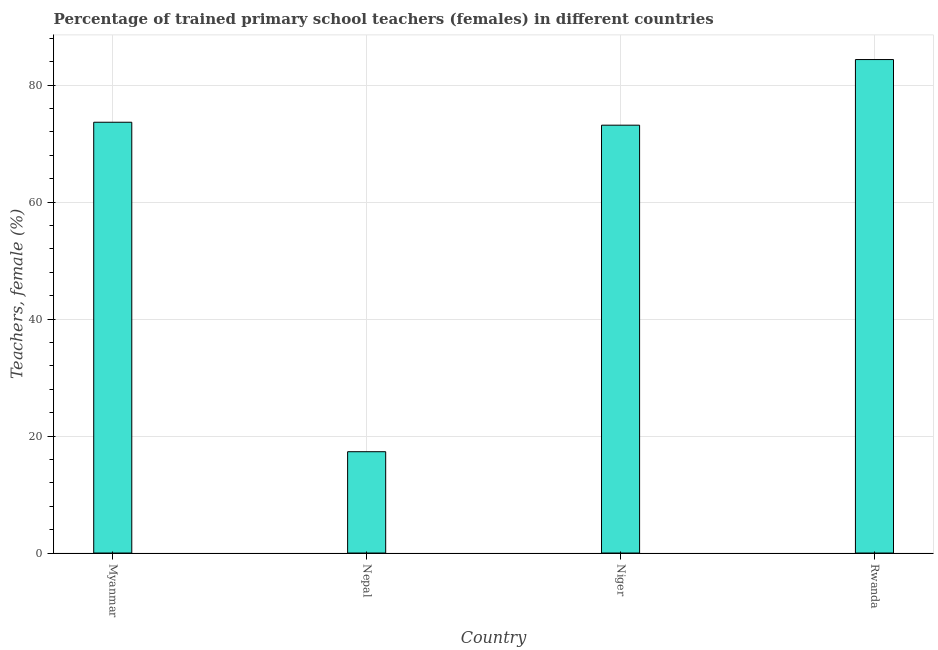What is the title of the graph?
Give a very brief answer. Percentage of trained primary school teachers (females) in different countries. What is the label or title of the X-axis?
Provide a succinct answer. Country. What is the label or title of the Y-axis?
Your answer should be very brief. Teachers, female (%). What is the percentage of trained female teachers in Myanmar?
Ensure brevity in your answer.  73.66. Across all countries, what is the maximum percentage of trained female teachers?
Offer a very short reply. 84.39. Across all countries, what is the minimum percentage of trained female teachers?
Ensure brevity in your answer.  17.32. In which country was the percentage of trained female teachers maximum?
Provide a short and direct response. Rwanda. In which country was the percentage of trained female teachers minimum?
Ensure brevity in your answer.  Nepal. What is the sum of the percentage of trained female teachers?
Offer a very short reply. 248.54. What is the difference between the percentage of trained female teachers in Niger and Rwanda?
Offer a terse response. -11.22. What is the average percentage of trained female teachers per country?
Give a very brief answer. 62.13. What is the median percentage of trained female teachers?
Give a very brief answer. 73.41. What is the ratio of the percentage of trained female teachers in Myanmar to that in Rwanda?
Make the answer very short. 0.87. Is the percentage of trained female teachers in Myanmar less than that in Rwanda?
Make the answer very short. Yes. What is the difference between the highest and the second highest percentage of trained female teachers?
Your answer should be very brief. 10.72. Is the sum of the percentage of trained female teachers in Niger and Rwanda greater than the maximum percentage of trained female teachers across all countries?
Your answer should be very brief. Yes. What is the difference between the highest and the lowest percentage of trained female teachers?
Make the answer very short. 67.06. In how many countries, is the percentage of trained female teachers greater than the average percentage of trained female teachers taken over all countries?
Make the answer very short. 3. How many bars are there?
Offer a terse response. 4. Are all the bars in the graph horizontal?
Your answer should be very brief. No. How many countries are there in the graph?
Offer a very short reply. 4. What is the difference between two consecutive major ticks on the Y-axis?
Your answer should be compact. 20. Are the values on the major ticks of Y-axis written in scientific E-notation?
Ensure brevity in your answer.  No. What is the Teachers, female (%) of Myanmar?
Keep it short and to the point. 73.66. What is the Teachers, female (%) in Nepal?
Your answer should be compact. 17.32. What is the Teachers, female (%) of Niger?
Your answer should be very brief. 73.16. What is the Teachers, female (%) of Rwanda?
Provide a succinct answer. 84.39. What is the difference between the Teachers, female (%) in Myanmar and Nepal?
Make the answer very short. 56.34. What is the difference between the Teachers, female (%) in Myanmar and Niger?
Keep it short and to the point. 0.5. What is the difference between the Teachers, female (%) in Myanmar and Rwanda?
Keep it short and to the point. -10.72. What is the difference between the Teachers, female (%) in Nepal and Niger?
Offer a very short reply. -55.84. What is the difference between the Teachers, female (%) in Nepal and Rwanda?
Offer a terse response. -67.06. What is the difference between the Teachers, female (%) in Niger and Rwanda?
Offer a very short reply. -11.22. What is the ratio of the Teachers, female (%) in Myanmar to that in Nepal?
Give a very brief answer. 4.25. What is the ratio of the Teachers, female (%) in Myanmar to that in Niger?
Give a very brief answer. 1.01. What is the ratio of the Teachers, female (%) in Myanmar to that in Rwanda?
Keep it short and to the point. 0.87. What is the ratio of the Teachers, female (%) in Nepal to that in Niger?
Your response must be concise. 0.24. What is the ratio of the Teachers, female (%) in Nepal to that in Rwanda?
Provide a succinct answer. 0.2. What is the ratio of the Teachers, female (%) in Niger to that in Rwanda?
Keep it short and to the point. 0.87. 